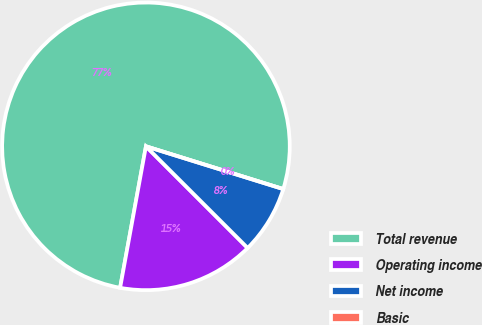<chart> <loc_0><loc_0><loc_500><loc_500><pie_chart><fcel>Total revenue<fcel>Operating income<fcel>Net income<fcel>Basic<nl><fcel>76.92%<fcel>15.38%<fcel>7.69%<fcel>0.0%<nl></chart> 